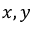<formula> <loc_0><loc_0><loc_500><loc_500>x , y</formula> 